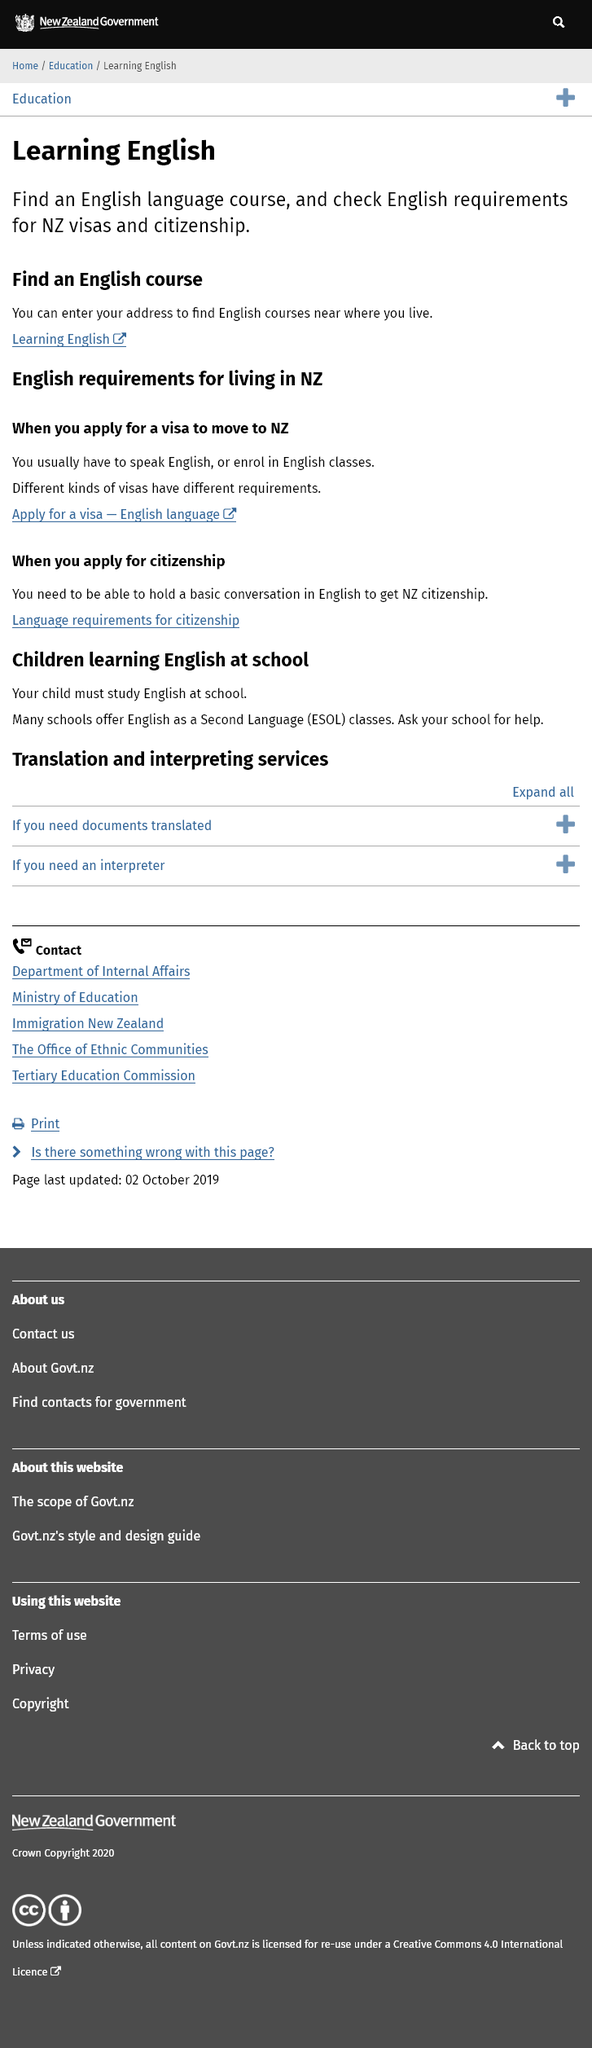Highlight a few significant elements in this photo. There are different kinds of visas available for individuals wishing to move to New Zealand. To obtain New Zealand citizenship, one must possess the ability to hold a basic conversation in the English language. It is a requirement for children to study English at school in New Zealand. 